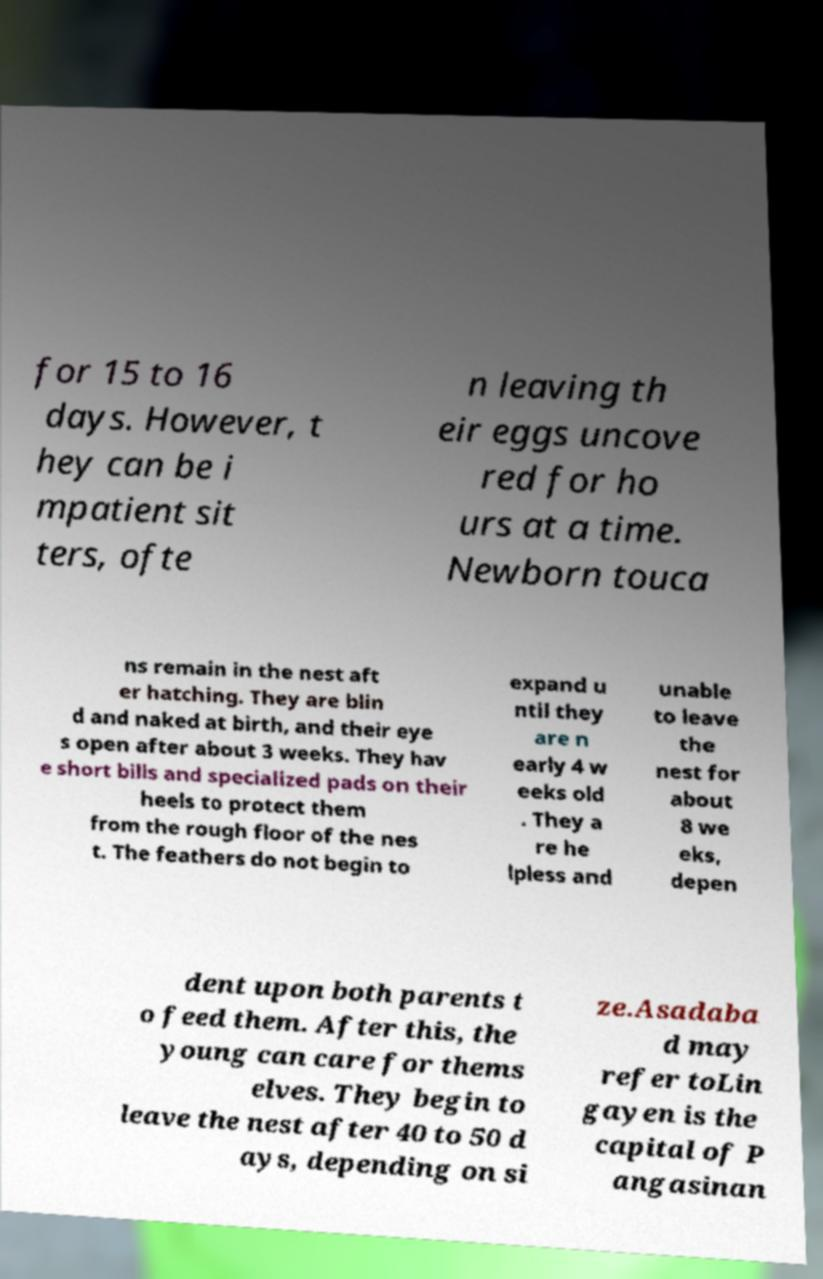Can you accurately transcribe the text from the provided image for me? for 15 to 16 days. However, t hey can be i mpatient sit ters, ofte n leaving th eir eggs uncove red for ho urs at a time. Newborn touca ns remain in the nest aft er hatching. They are blin d and naked at birth, and their eye s open after about 3 weeks. They hav e short bills and specialized pads on their heels to protect them from the rough floor of the nes t. The feathers do not begin to expand u ntil they are n early 4 w eeks old . They a re he lpless and unable to leave the nest for about 8 we eks, depen dent upon both parents t o feed them. After this, the young can care for thems elves. They begin to leave the nest after 40 to 50 d ays, depending on si ze.Asadaba d may refer toLin gayen is the capital of P angasinan 